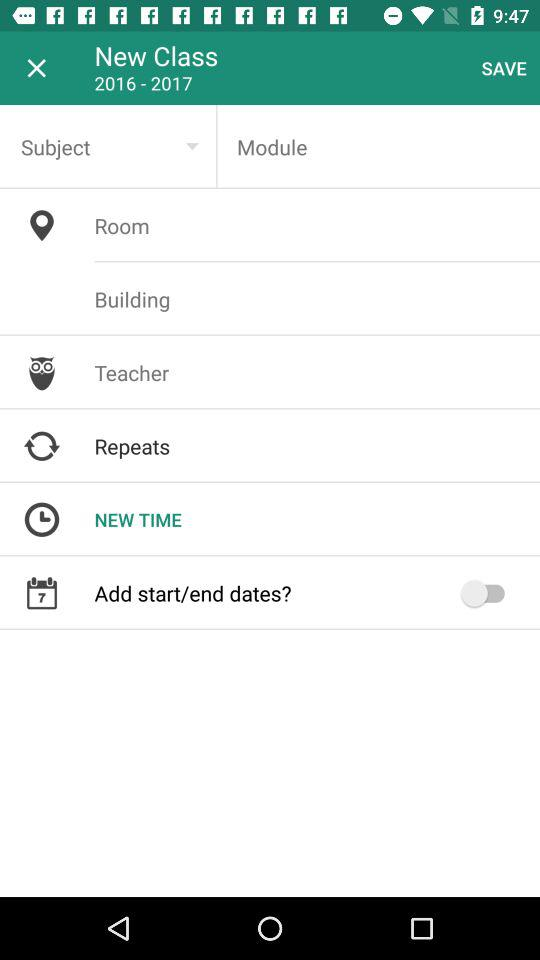What is the status of the "Add start/end dates?"? The status of the "Add start/end dates?" is "off". 